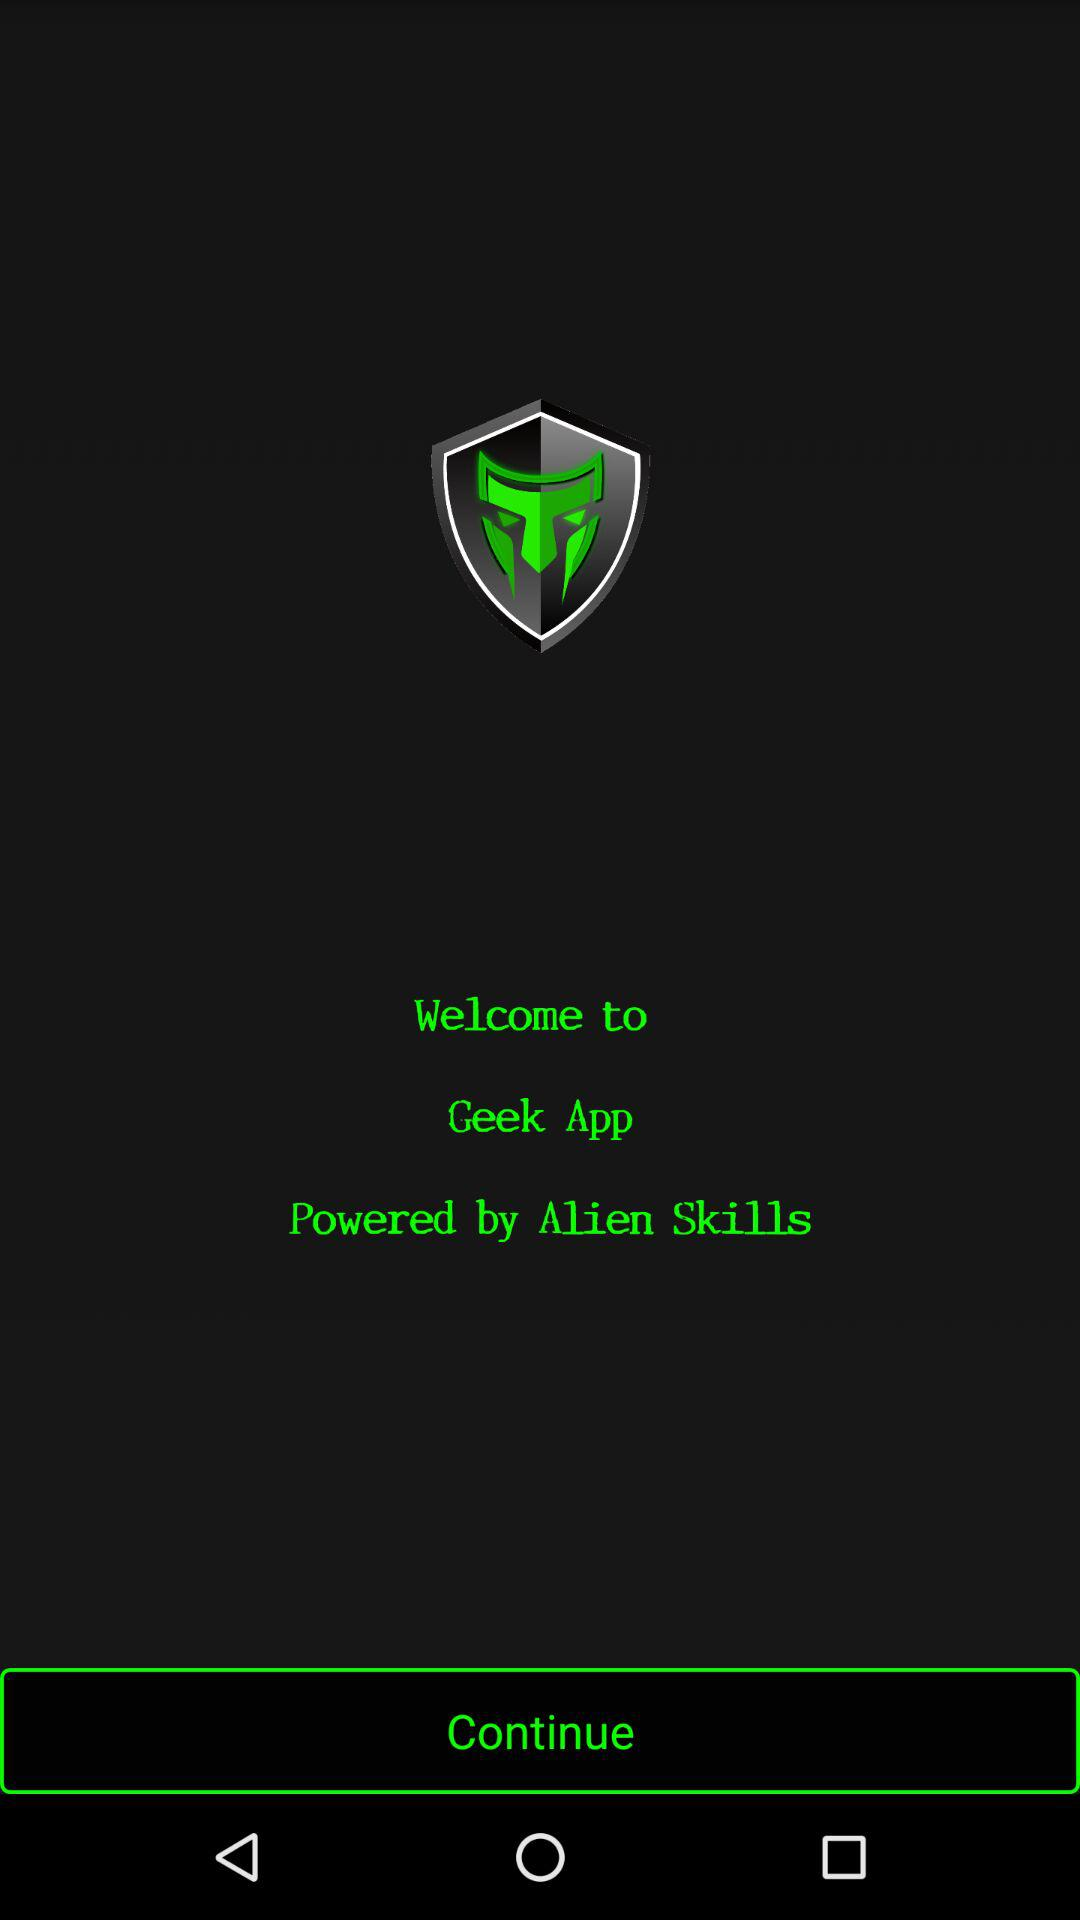What is the name of the application? The name of the application is "Geek". 